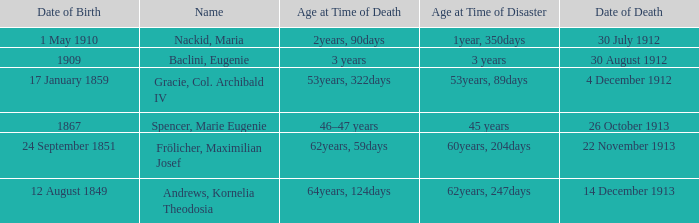When did the person born 24 September 1851 pass away? 22 November 1913. 